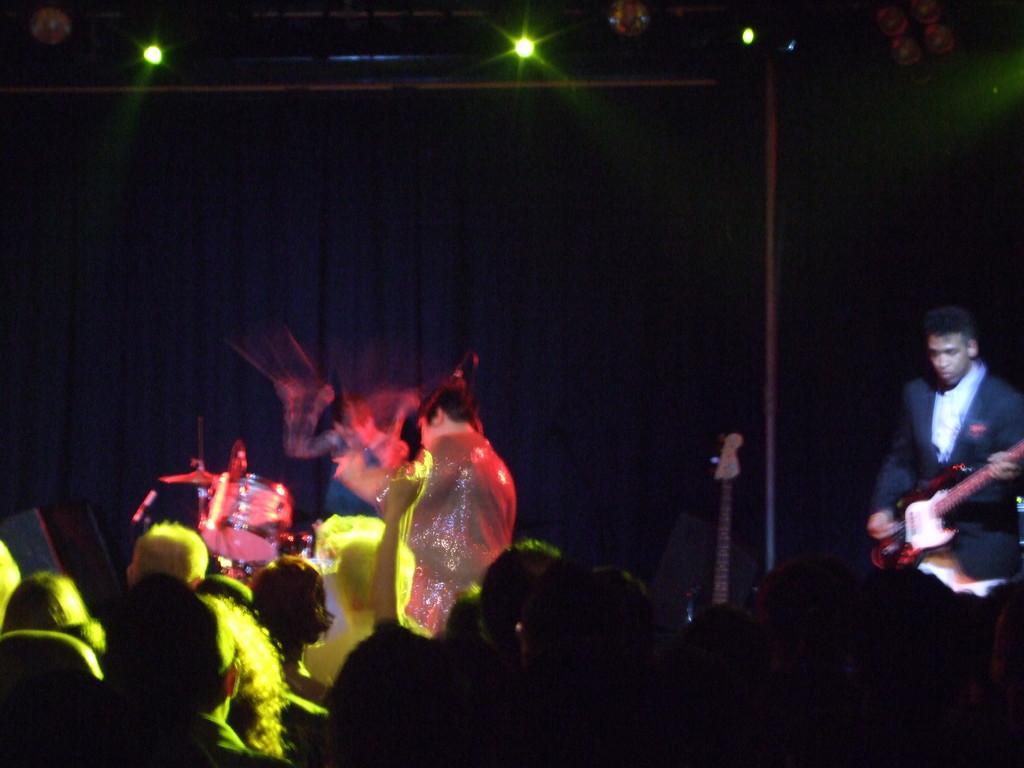In one or two sentences, can you explain what this image depicts? In the center of the image we can see the drums, a man is standing and holding a guitar are present. In the background of the image there is a lights, curtain are present. At the bottom of the image a group of people are there. 